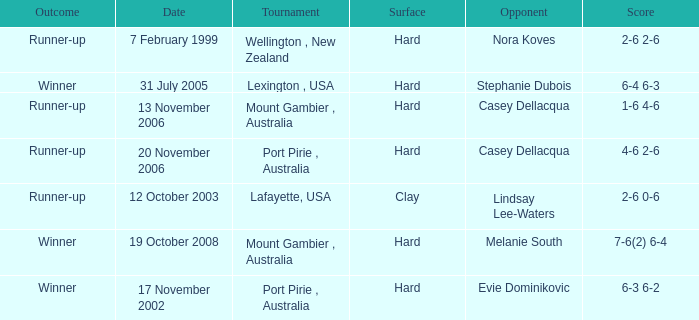When is an Opponent of evie dominikovic? 17 November 2002. 